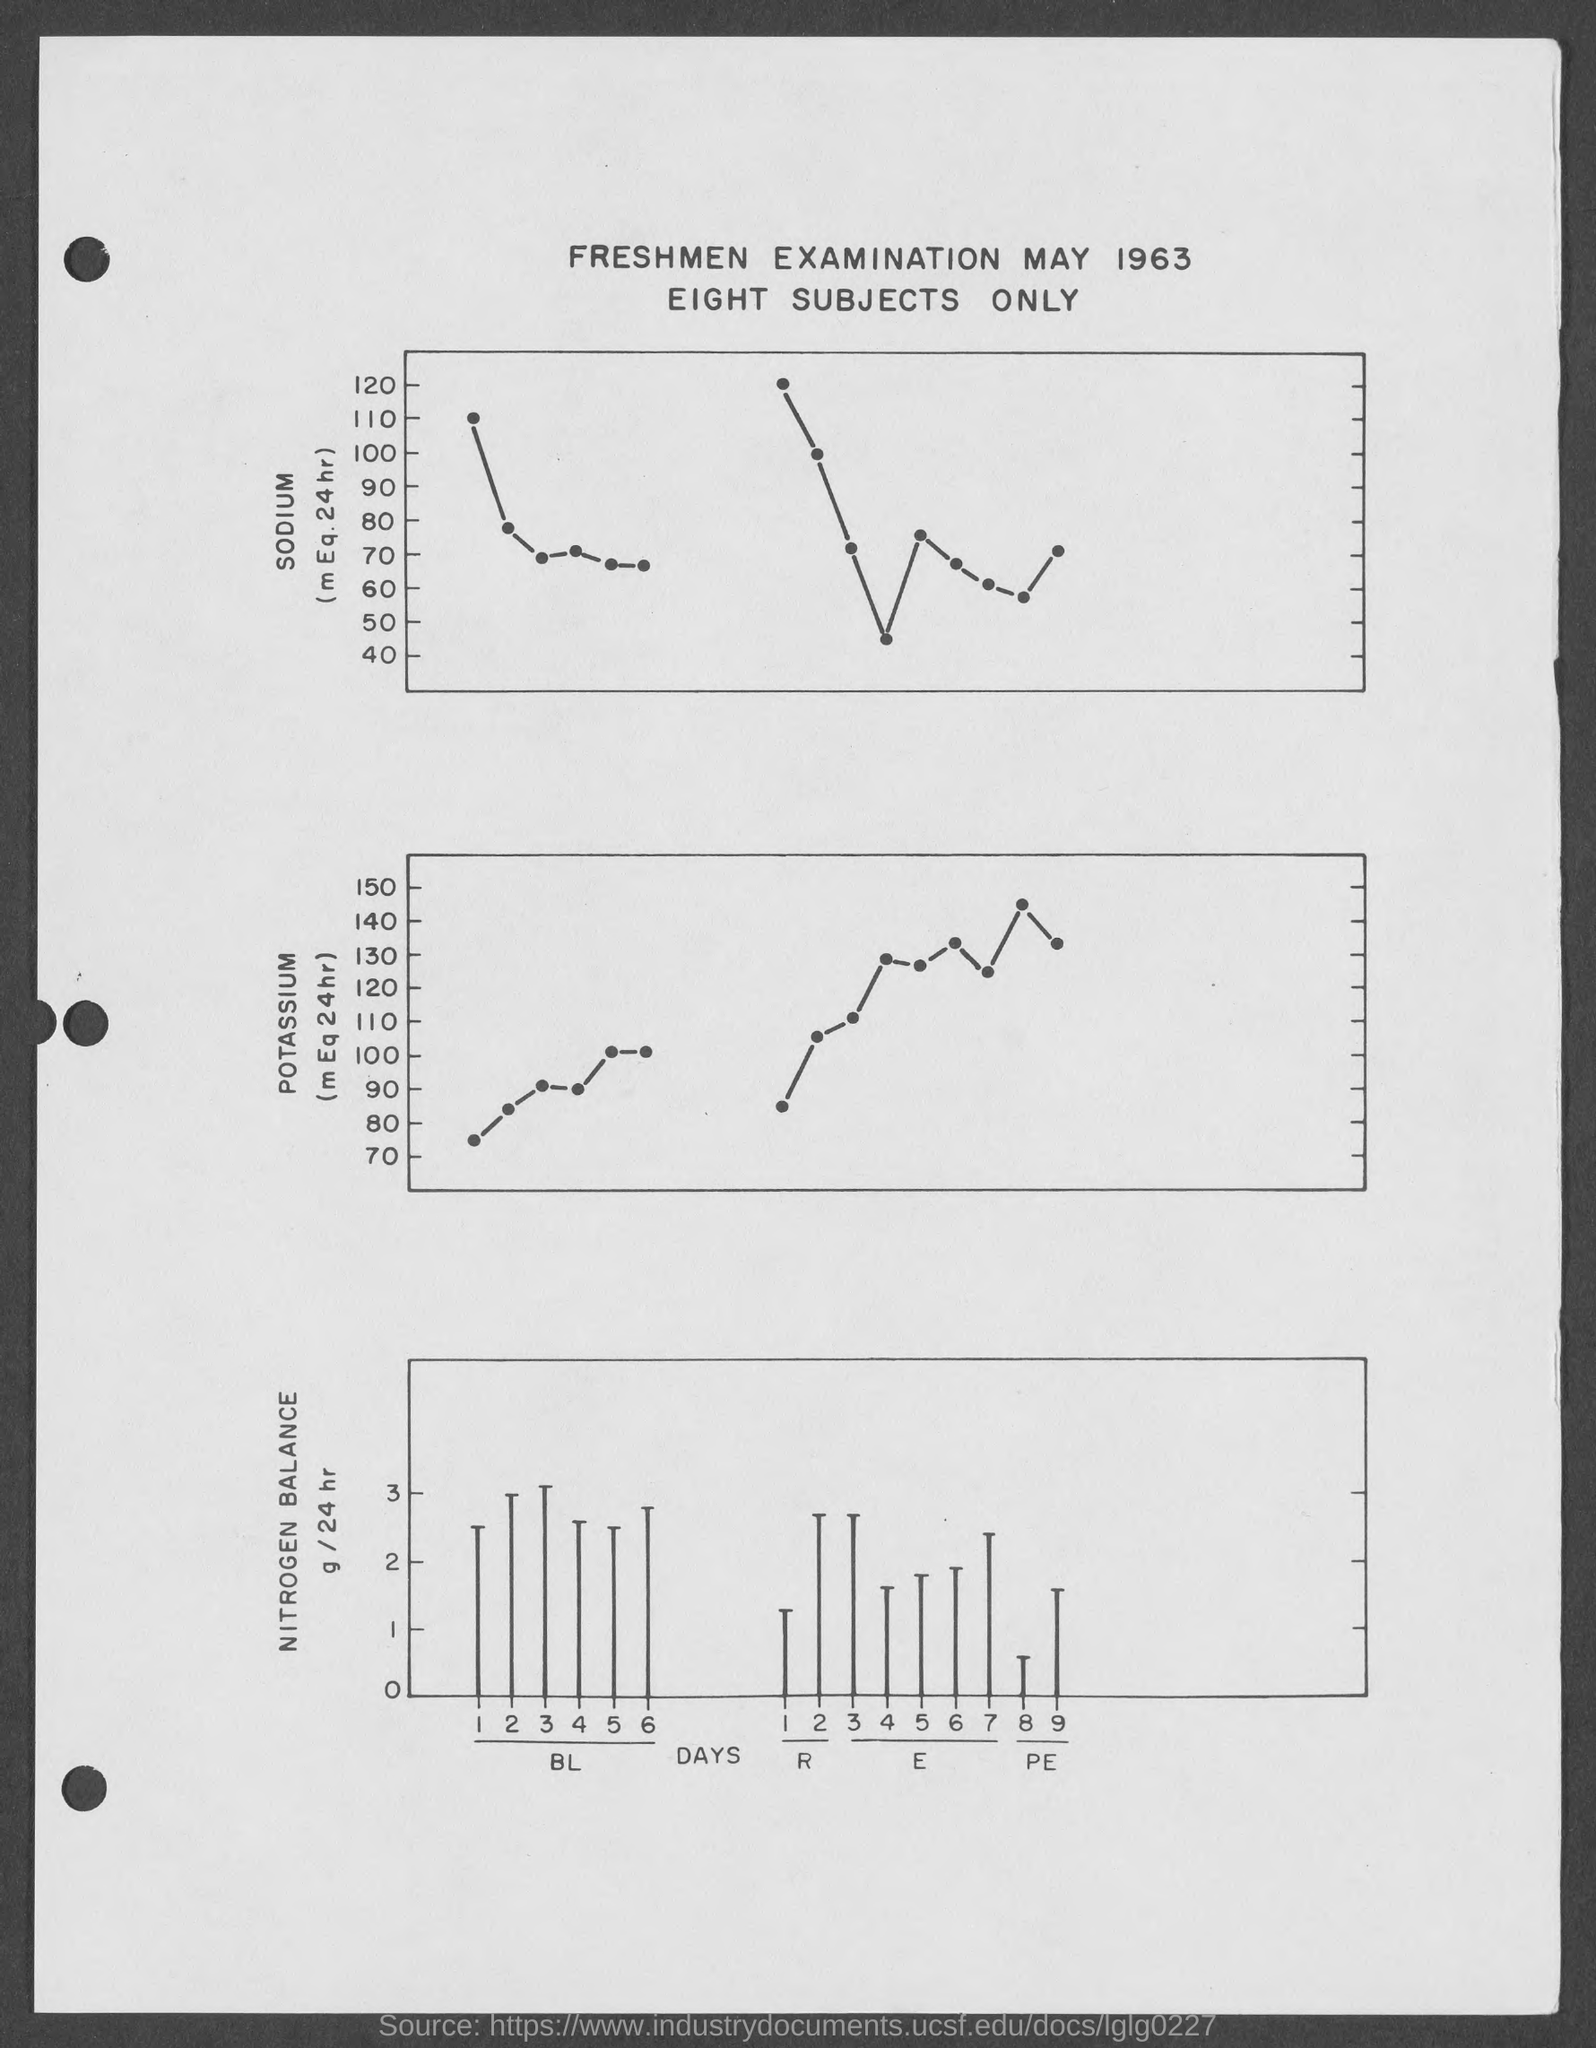When is the freshmen examination on?
Offer a terse response. May 1963. How many number of subjects are there?
Ensure brevity in your answer.  Eight. 